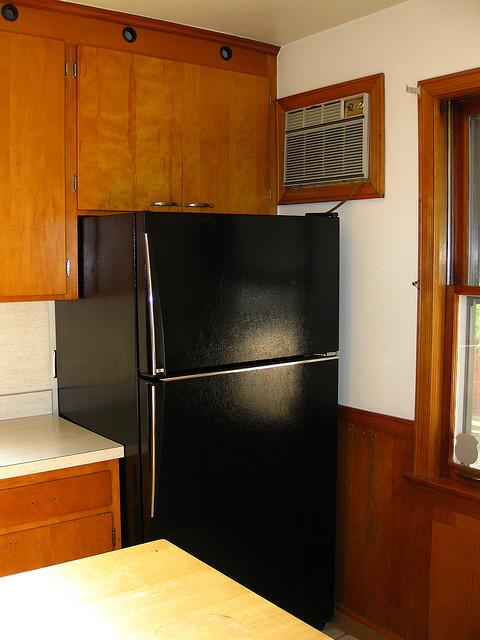Is the refrigerator a French doors?
Quick response, please. No. What color are the cabinets?
Write a very short answer. Brown. What is the color of refrigerator?
Short answer required. Black. Does this home have central air?
Short answer required. No. 